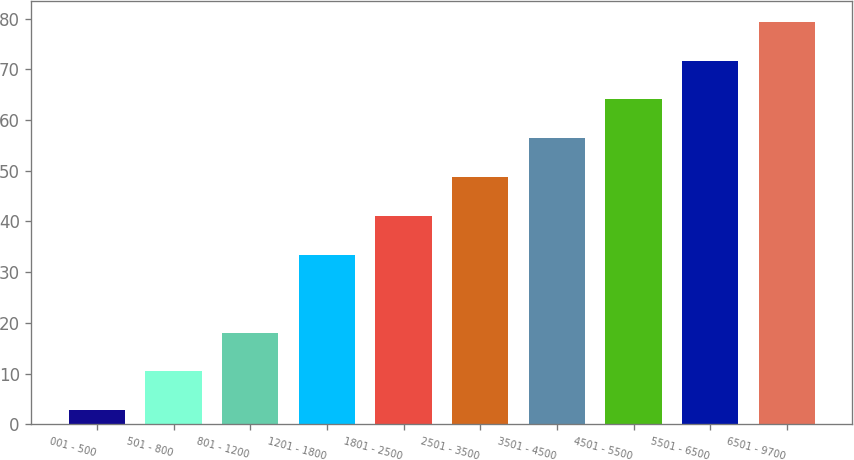Convert chart to OTSL. <chart><loc_0><loc_0><loc_500><loc_500><bar_chart><fcel>001 - 500<fcel>501 - 800<fcel>801 - 1200<fcel>1201 - 1800<fcel>1801 - 2500<fcel>2501 - 3500<fcel>3501 - 4500<fcel>4501 - 5500<fcel>5501 - 6500<fcel>6501 - 9700<nl><fcel>2.76<fcel>10.42<fcel>18.08<fcel>33.4<fcel>41.06<fcel>48.72<fcel>56.38<fcel>64.04<fcel>71.7<fcel>79.39<nl></chart> 